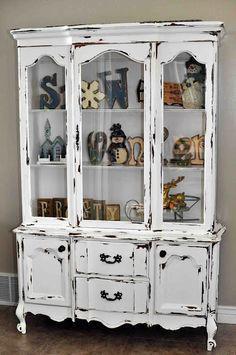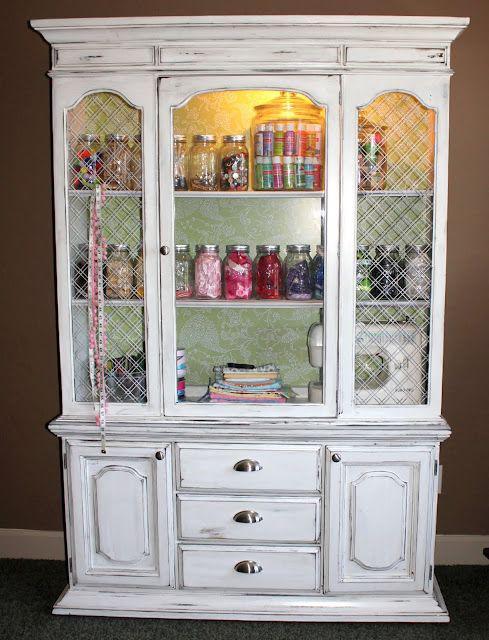The first image is the image on the left, the second image is the image on the right. For the images shown, is this caption "One of the cabinets is empty inside." true? Answer yes or no. No. The first image is the image on the left, the second image is the image on the right. Given the left and right images, does the statement "the right pic furniture piece has 3 or more glass panels" hold true? Answer yes or no. Yes. 